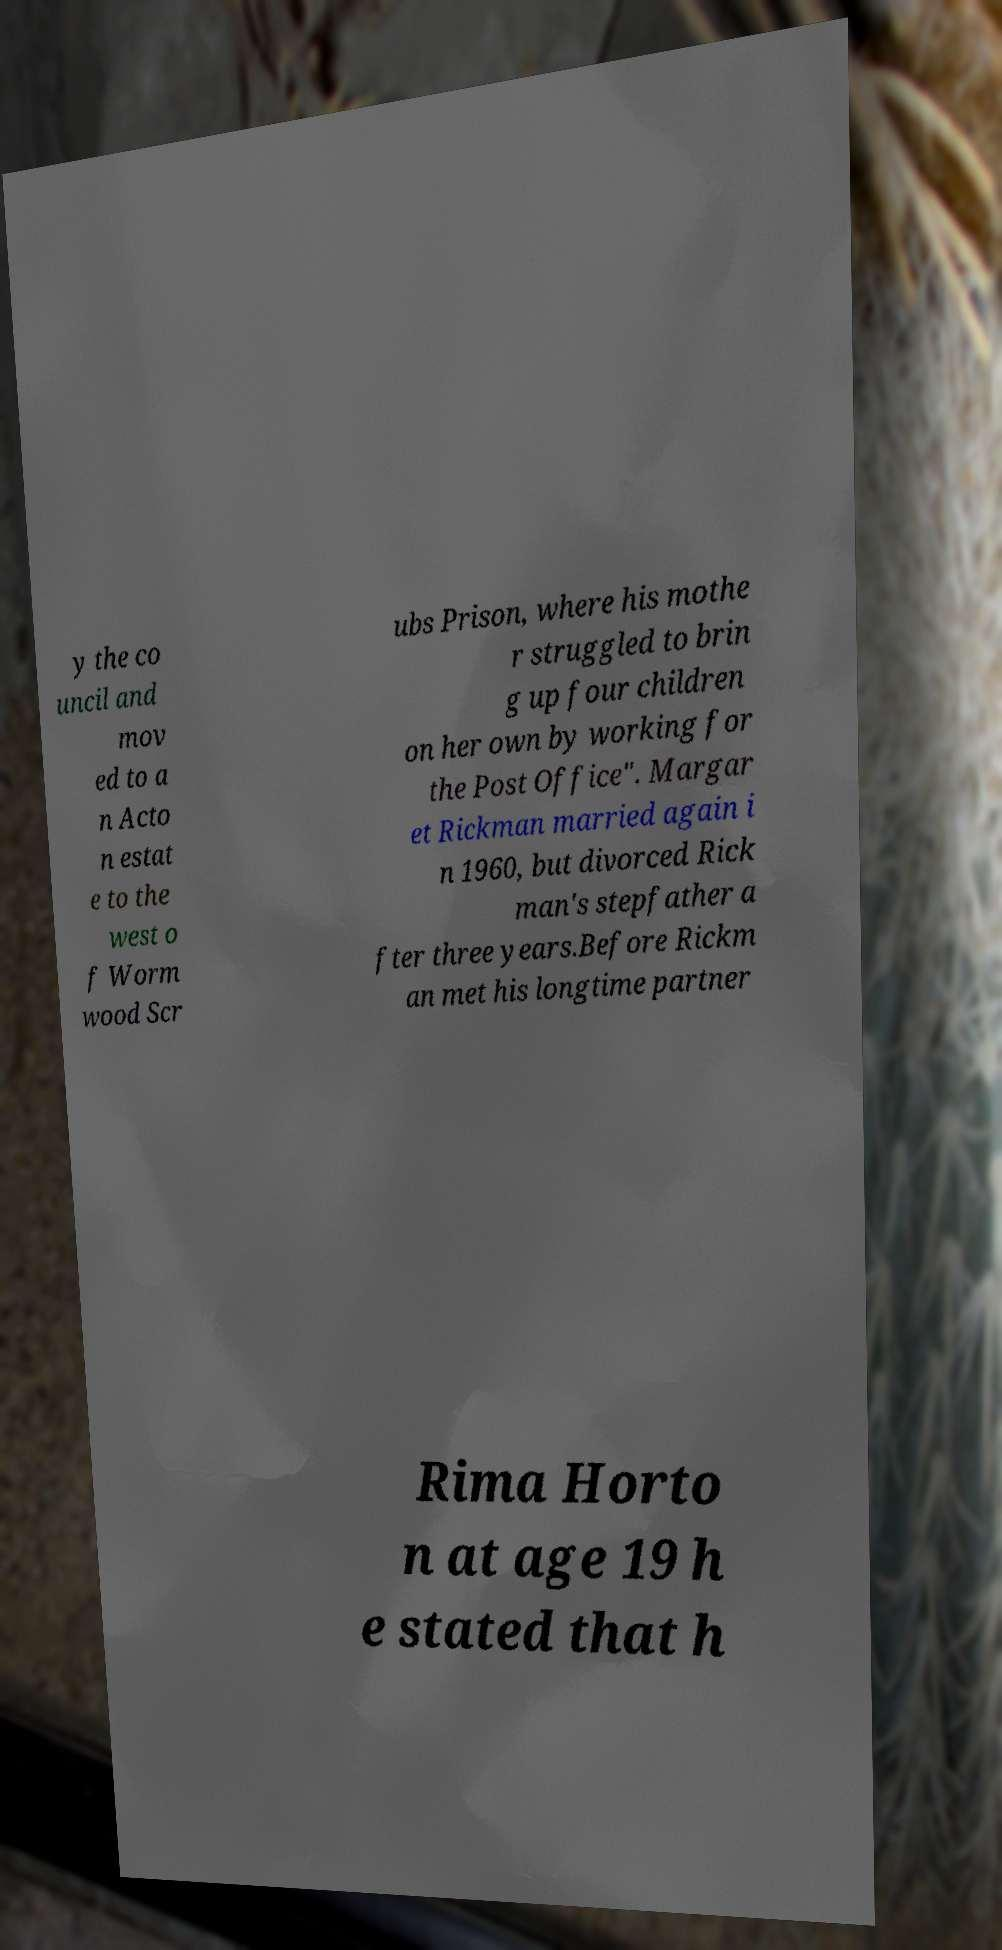Can you read and provide the text displayed in the image?This photo seems to have some interesting text. Can you extract and type it out for me? y the co uncil and mov ed to a n Acto n estat e to the west o f Worm wood Scr ubs Prison, where his mothe r struggled to brin g up four children on her own by working for the Post Office". Margar et Rickman married again i n 1960, but divorced Rick man's stepfather a fter three years.Before Rickm an met his longtime partner Rima Horto n at age 19 h e stated that h 